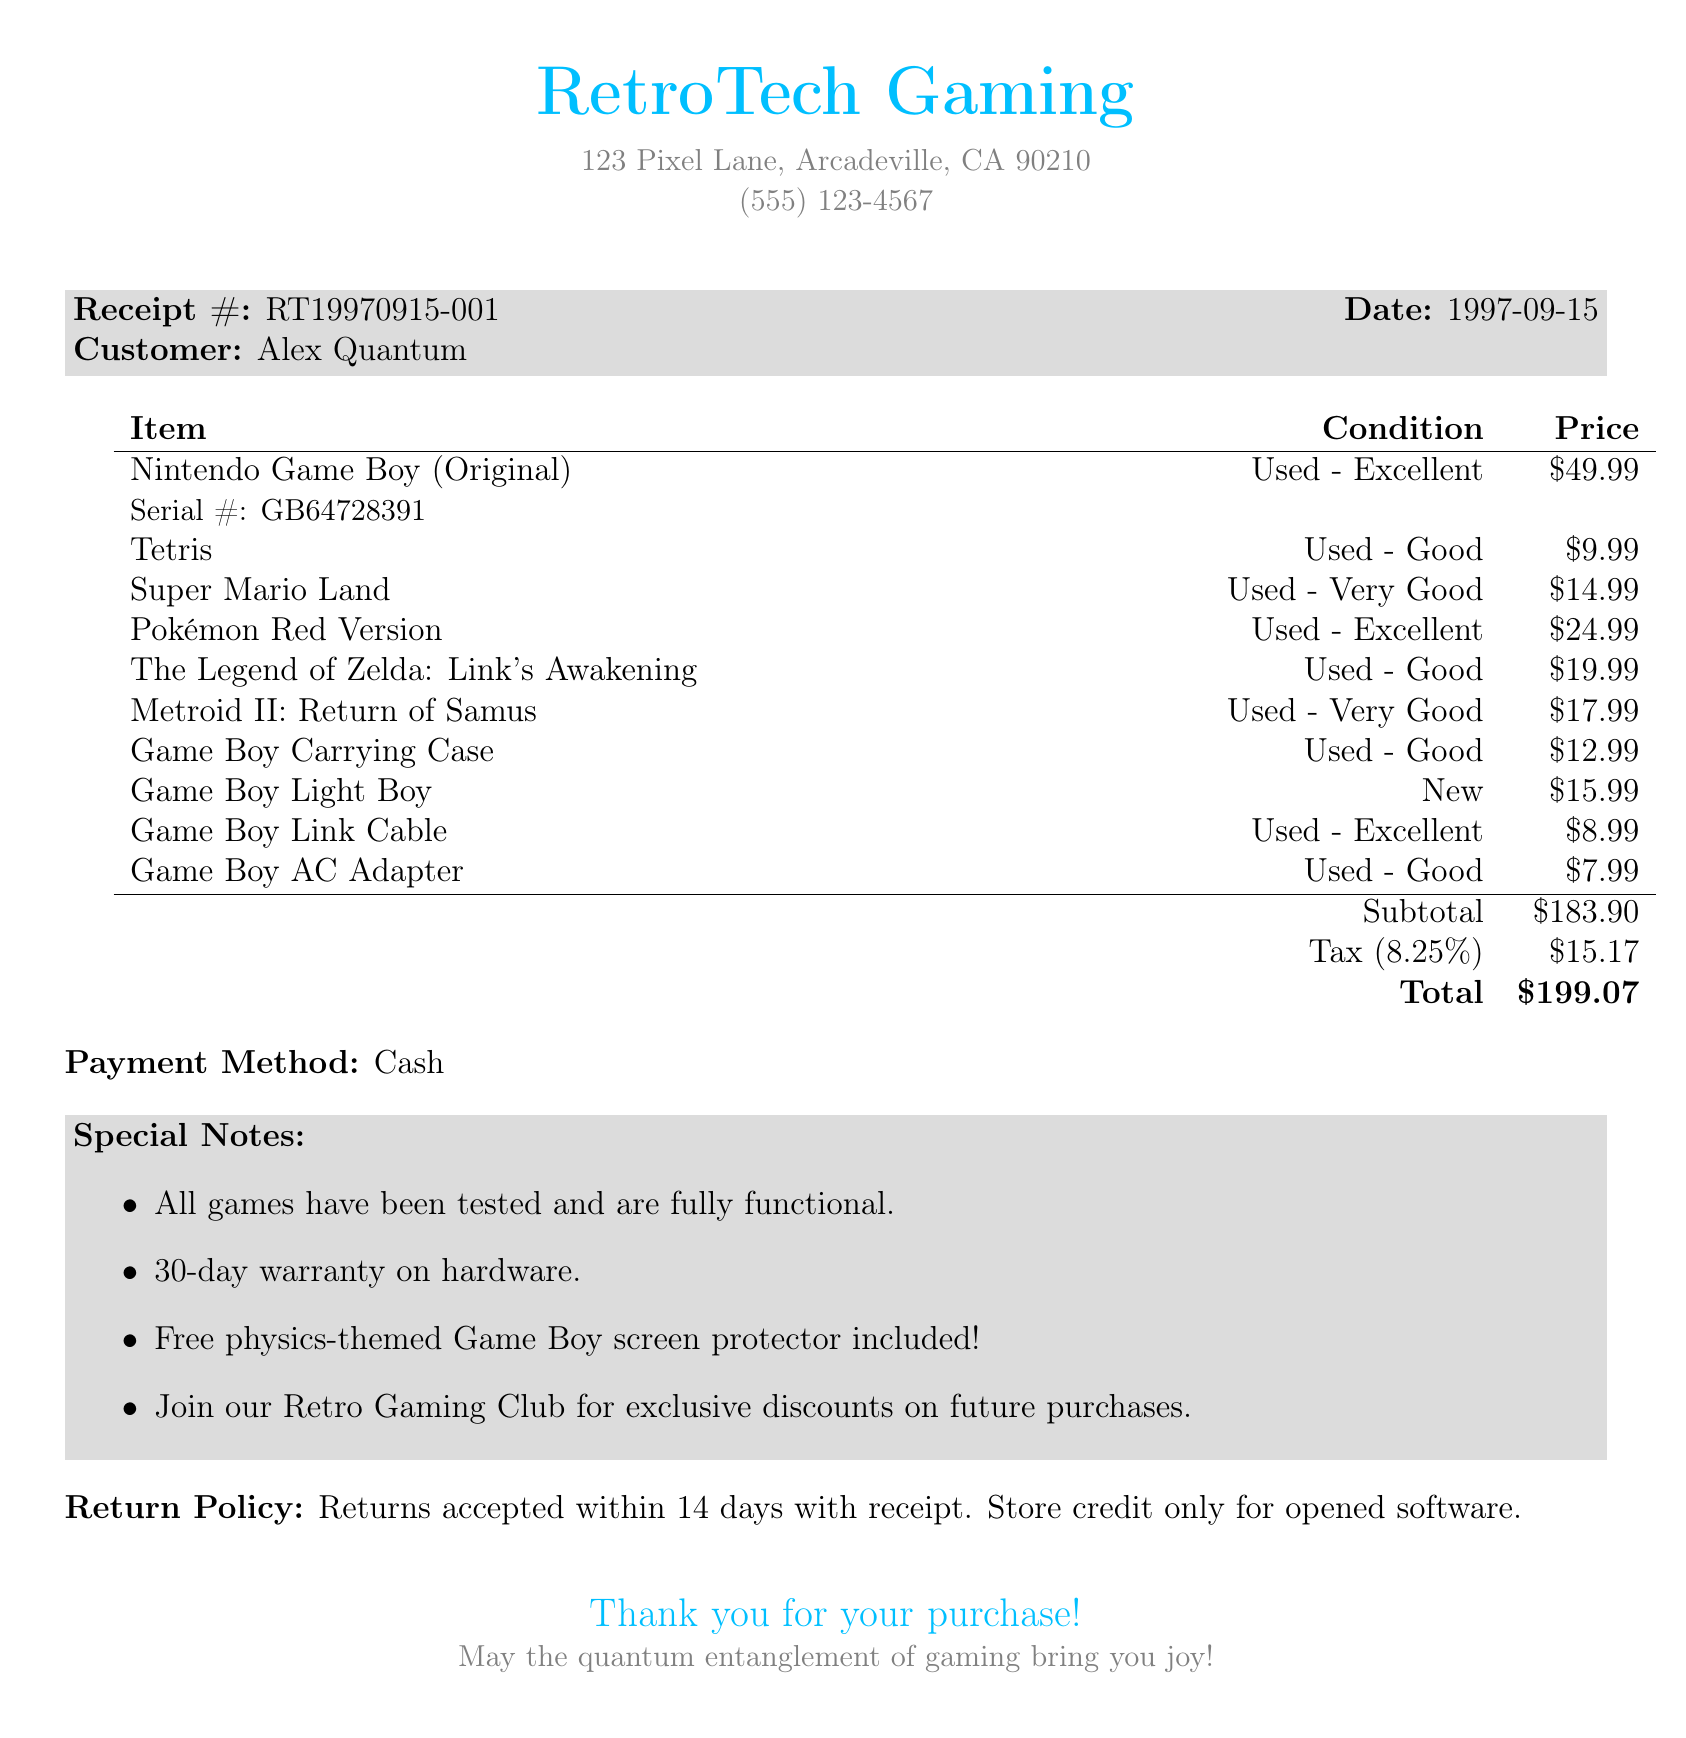What is the store name? The store name is prominently displayed at the top of the document.
Answer: RetroTech Gaming What is the date of the purchase? The date is clearly stated in the receipt details.
Answer: 1997-09-15 What is the total amount spent? The total amount is calculated at the bottom of the receipt and is denoted as the final value.
Answer: $199.07 How many games were included? Counting the items listed will show the number of games in the purchase.
Answer: 6 What is the condition of the Game Boy? The condition of the Game Boy is specified next to its name on the list.
Answer: Used - Excellent What special note was included about the games? The special notes section lists details about the games' functionality.
Answer: All games have been tested and are fully functional What is the return policy? The return policy is explicitly mentioned at the end of the receipt.
Answer: Returns accepted within 14 days with receipt What type of payment was used? The payment method is stated clearly on the receipt.
Answer: Cash What is the serial number of the Nintendo Game Boy? The serial number is provided in the details of the Game Boy item.
Answer: GB64728391 